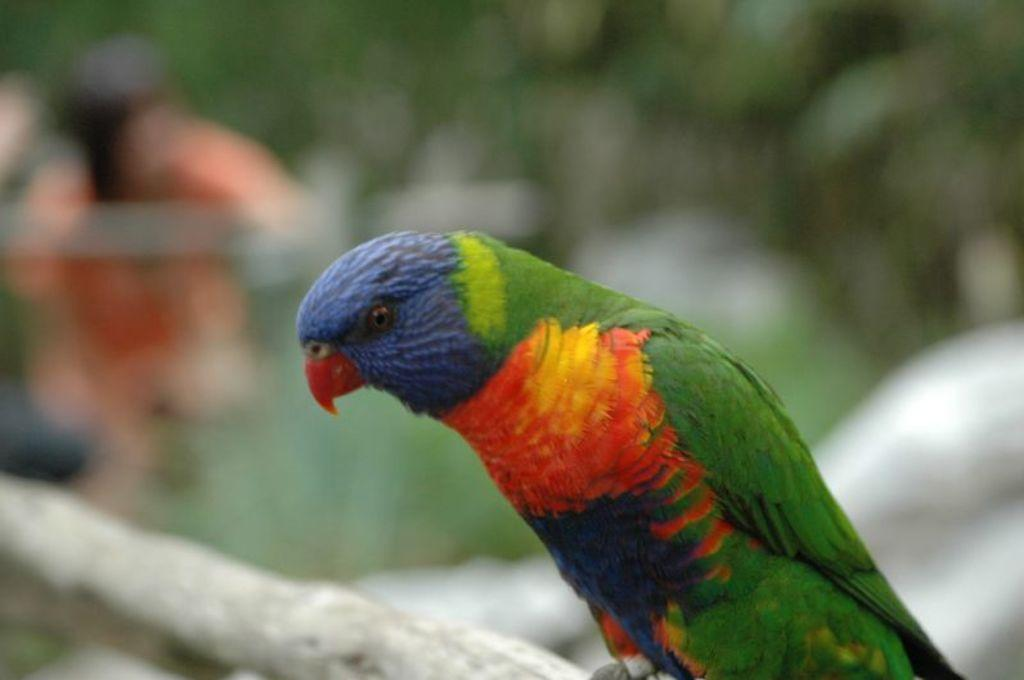What is the main subject in the center of the image? There is a bird in the center of the image. Can you describe the background of the image? The background of the image is blurry. How many horses can be seen in the image? There are no horses present in the image; it features a bird in the center. What type of ink is being used by the pest in the image? There is no pest or ink present in the image. 